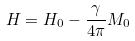Convert formula to latex. <formula><loc_0><loc_0><loc_500><loc_500>H = H _ { 0 } - \frac { \gamma } { 4 \pi } M _ { 0 }</formula> 